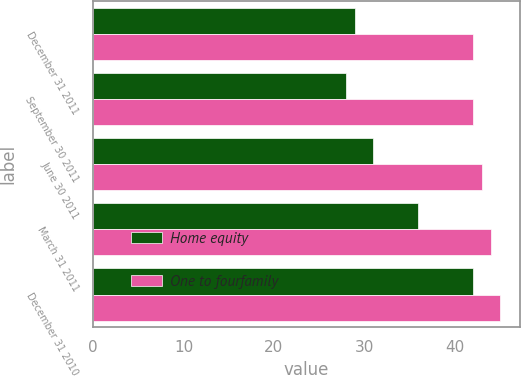Convert chart. <chart><loc_0><loc_0><loc_500><loc_500><stacked_bar_chart><ecel><fcel>December 31 2011<fcel>September 30 2011<fcel>June 30 2011<fcel>March 31 2011<fcel>December 31 2010<nl><fcel>Home equity<fcel>29<fcel>28<fcel>31<fcel>36<fcel>42<nl><fcel>One to fourfamily<fcel>42<fcel>42<fcel>43<fcel>44<fcel>45<nl></chart> 